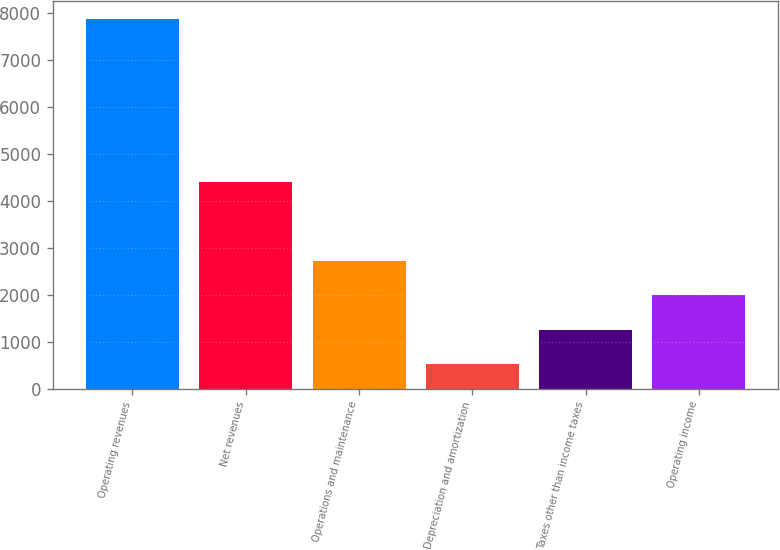Convert chart. <chart><loc_0><loc_0><loc_500><loc_500><bar_chart><fcel>Operating revenues<fcel>Net revenues<fcel>Operations and maintenance<fcel>Depreciation and amortization<fcel>Taxes other than income taxes<fcel>Operating income<nl><fcel>7878<fcel>4410<fcel>2728.1<fcel>521<fcel>1256.7<fcel>1992.4<nl></chart> 